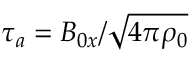Convert formula to latex. <formula><loc_0><loc_0><loc_500><loc_500>\tau _ { a } = B _ { 0 x } / \sqrt { 4 \pi \rho _ { 0 } }</formula> 